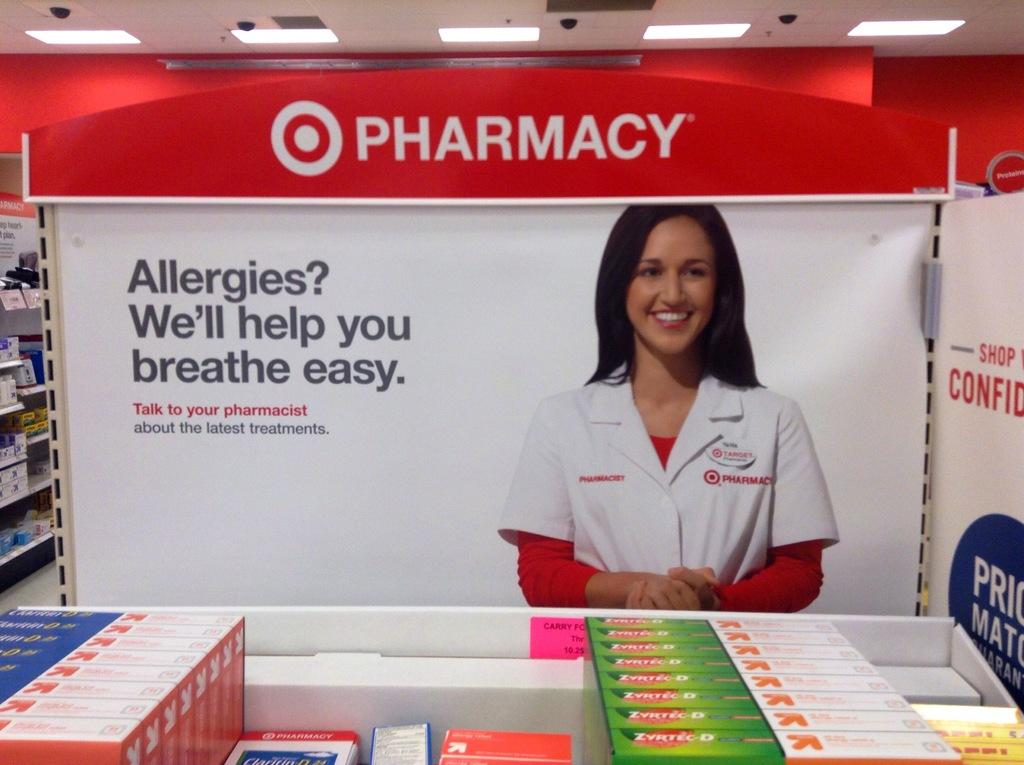Provide a one-sentence caption for the provided image. Pharmacy that sells medicine for allergies that will help you breath easy. 